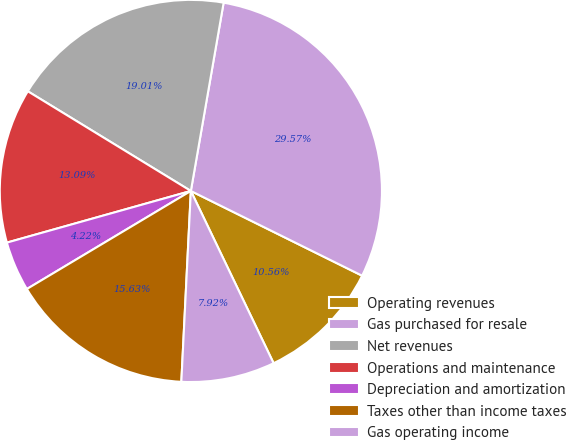Convert chart. <chart><loc_0><loc_0><loc_500><loc_500><pie_chart><fcel>Operating revenues<fcel>Gas purchased for resale<fcel>Net revenues<fcel>Operations and maintenance<fcel>Depreciation and amortization<fcel>Taxes other than income taxes<fcel>Gas operating income<nl><fcel>10.56%<fcel>29.57%<fcel>19.01%<fcel>13.09%<fcel>4.22%<fcel>15.63%<fcel>7.92%<nl></chart> 